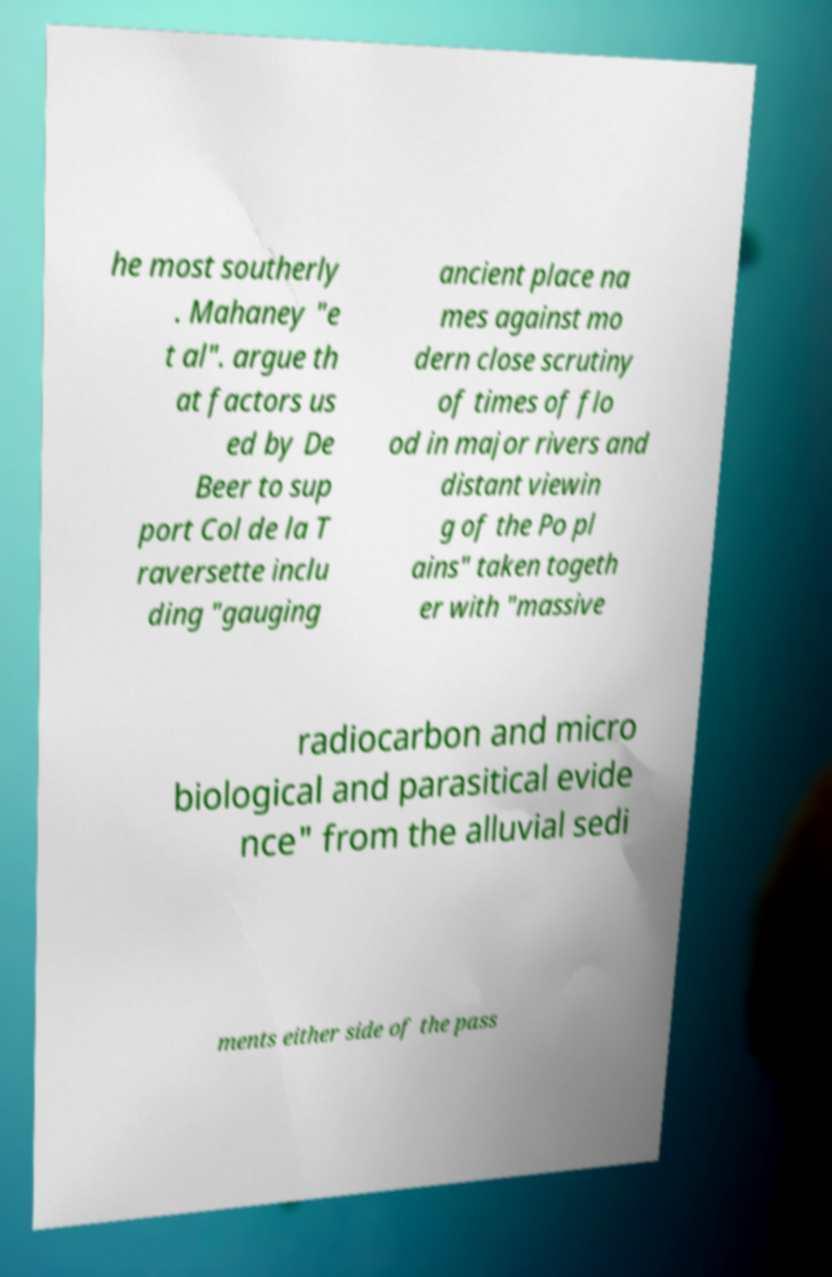What messages or text are displayed in this image? I need them in a readable, typed format. he most southerly . Mahaney "e t al". argue th at factors us ed by De Beer to sup port Col de la T raversette inclu ding "gauging ancient place na mes against mo dern close scrutiny of times of flo od in major rivers and distant viewin g of the Po pl ains" taken togeth er with "massive radiocarbon and micro biological and parasitical evide nce" from the alluvial sedi ments either side of the pass 